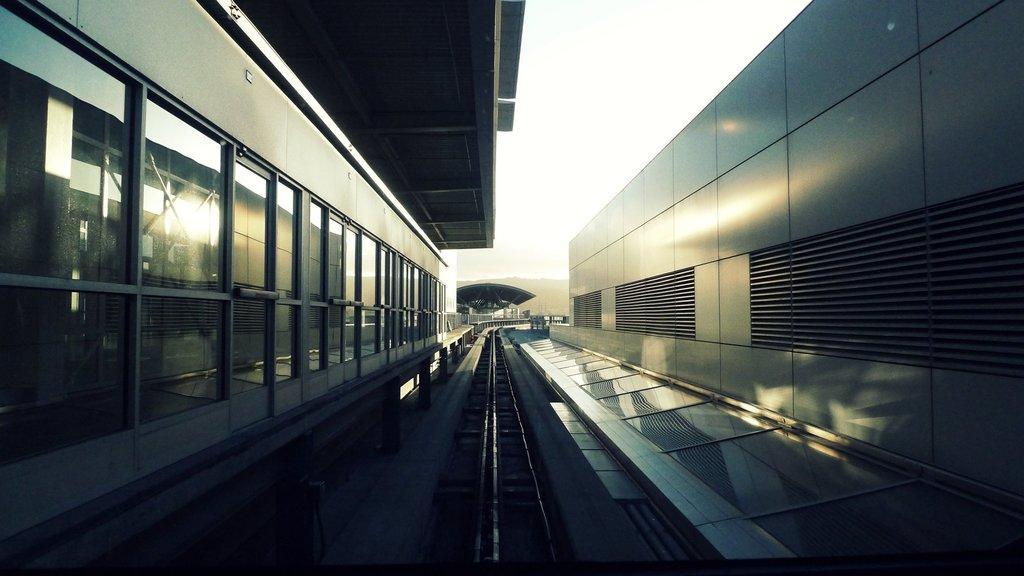How would you summarize this image in a sentence or two? This picture is taken inside the railway station. In this image, on the right side, we can see a wall with some grills. On the left side, we can see a building, glass window. In the background, we can see some roof, trees, mountains. At the top, we can see a sky, at the bottom, we can see a railway track. 